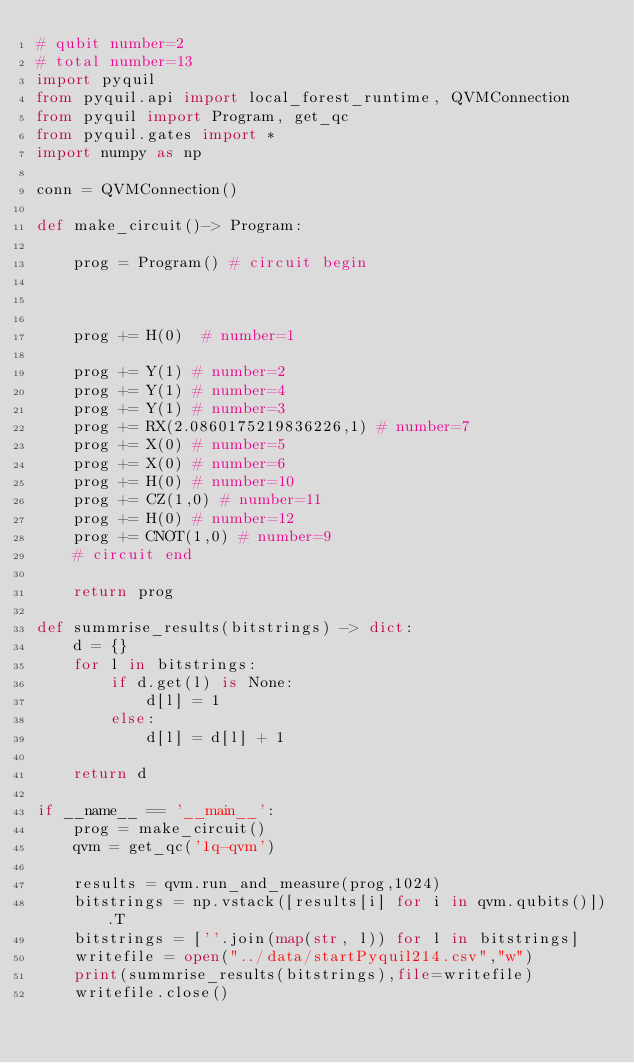<code> <loc_0><loc_0><loc_500><loc_500><_Python_># qubit number=2
# total number=13
import pyquil
from pyquil.api import local_forest_runtime, QVMConnection
from pyquil import Program, get_qc
from pyquil.gates import *
import numpy as np

conn = QVMConnection()

def make_circuit()-> Program:

    prog = Program() # circuit begin



    prog += H(0)  # number=1

    prog += Y(1) # number=2
    prog += Y(1) # number=4
    prog += Y(1) # number=3
    prog += RX(2.0860175219836226,1) # number=7
    prog += X(0) # number=5
    prog += X(0) # number=6
    prog += H(0) # number=10
    prog += CZ(1,0) # number=11
    prog += H(0) # number=12
    prog += CNOT(1,0) # number=9
    # circuit end

    return prog

def summrise_results(bitstrings) -> dict:
    d = {}
    for l in bitstrings:
        if d.get(l) is None:
            d[l] = 1
        else:
            d[l] = d[l] + 1

    return d

if __name__ == '__main__':
    prog = make_circuit()
    qvm = get_qc('1q-qvm')

    results = qvm.run_and_measure(prog,1024)
    bitstrings = np.vstack([results[i] for i in qvm.qubits()]).T
    bitstrings = [''.join(map(str, l)) for l in bitstrings]
    writefile = open("../data/startPyquil214.csv","w")
    print(summrise_results(bitstrings),file=writefile)
    writefile.close()

</code> 